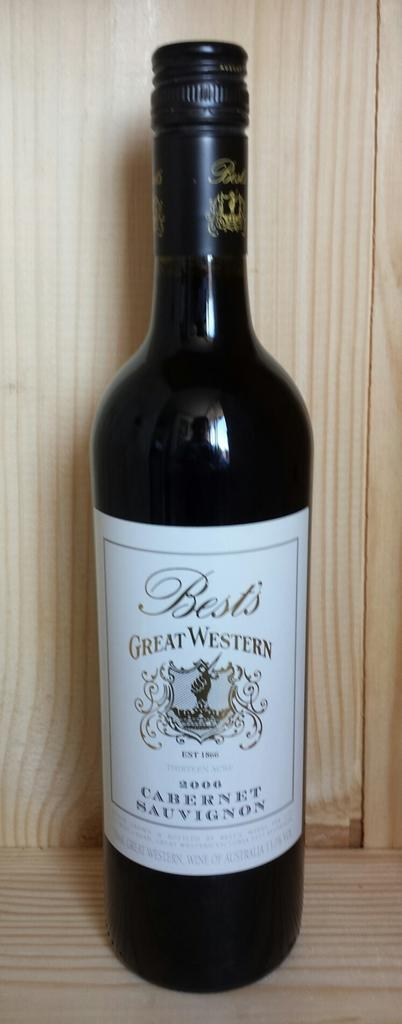<image>
Provide a brief description of the given image. The style of wine here is Cabernet Sauvignon 